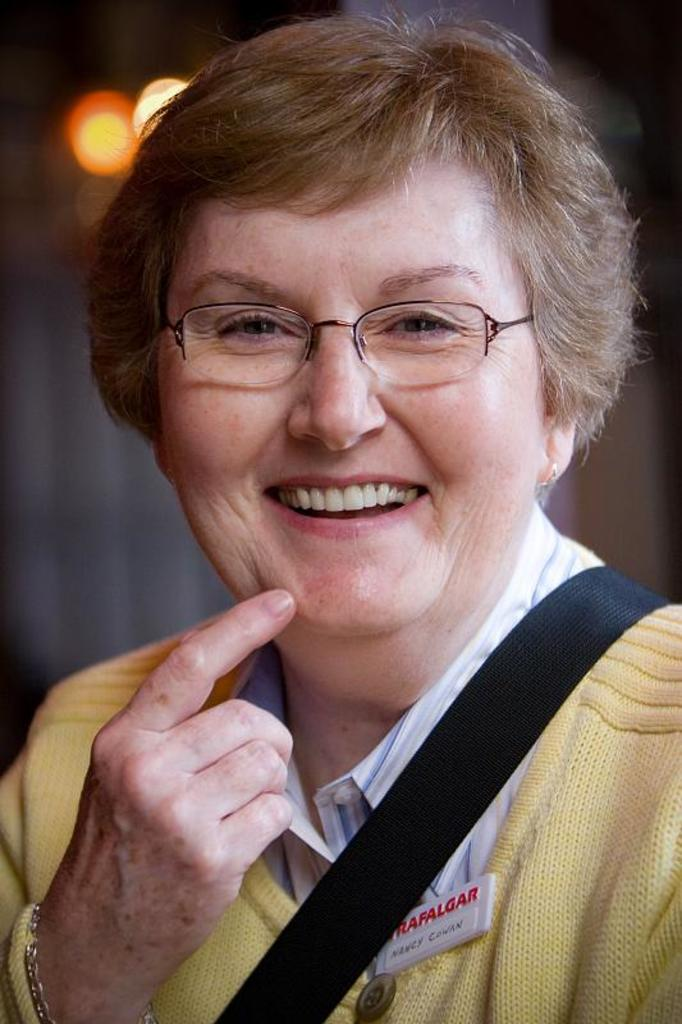What is the main subject of the image? There is a person in the image. Can you describe the background of the image? The background of the image is blurred. What type of horn does the scarecrow in the image have? There is no scarecrowcarecrow or horn present in the image. 